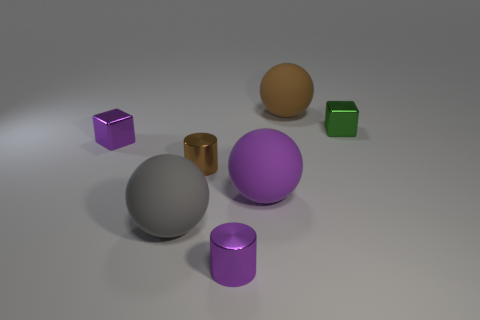Are there fewer small cylinders than tiny objects?
Offer a very short reply. Yes. What is the color of the cube that is to the left of the metallic cylinder in front of the tiny brown cylinder?
Provide a short and direct response. Purple. What is the material of the sphere that is behind the small cube right of the tiny purple object on the right side of the large gray matte sphere?
Your answer should be very brief. Rubber. There is a cylinder on the right side of the brown cylinder; is it the same size as the tiny brown cylinder?
Your response must be concise. Yes. What material is the purple object that is to the left of the large gray rubber object?
Provide a succinct answer. Metal. Is the number of cylinders greater than the number of large purple matte spheres?
Provide a short and direct response. Yes. What number of things are small shiny blocks that are behind the small purple block or tiny purple metal cylinders?
Make the answer very short. 2. There is a object that is to the right of the brown sphere; how many large purple balls are to the right of it?
Your response must be concise. 0. There is a block on the right side of the tiny purple object on the right side of the cube that is on the left side of the tiny green metallic cube; what is its size?
Ensure brevity in your answer.  Small. What is the size of the brown rubber thing that is the same shape as the gray object?
Your response must be concise. Large. 